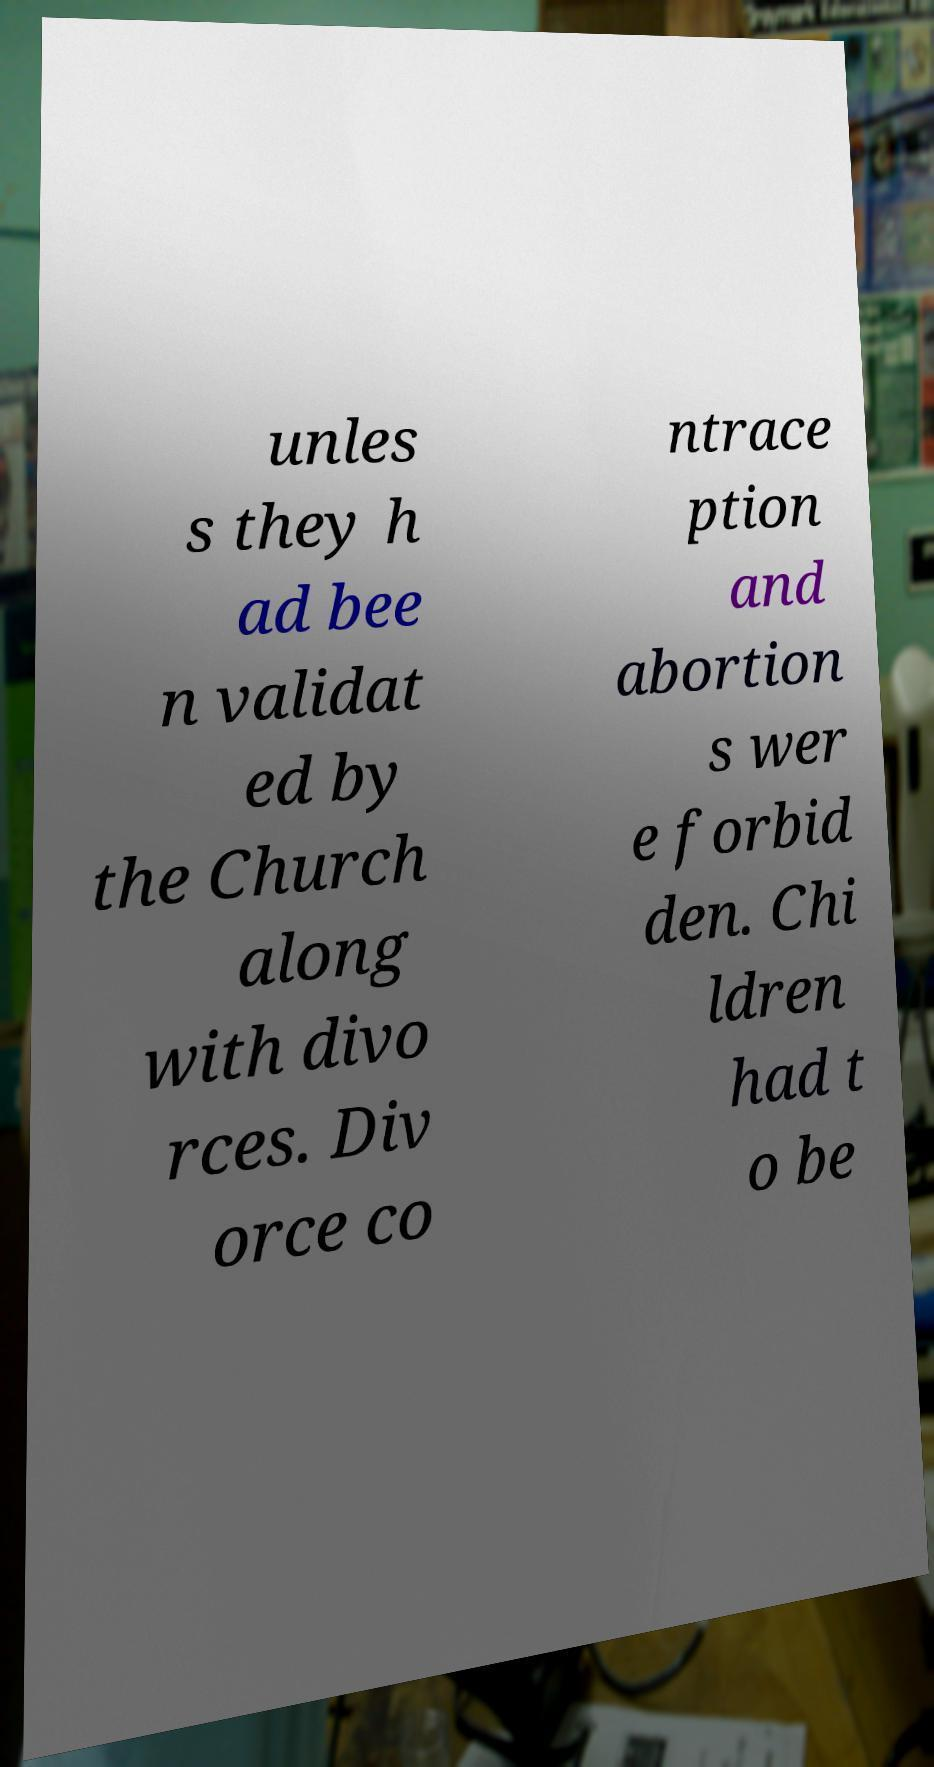Can you accurately transcribe the text from the provided image for me? unles s they h ad bee n validat ed by the Church along with divo rces. Div orce co ntrace ption and abortion s wer e forbid den. Chi ldren had t o be 